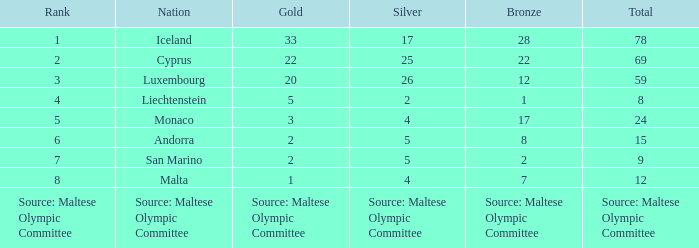What is the total medal count for the nation that has 5 gold? 8.0. 